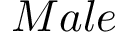Convert formula to latex. <formula><loc_0><loc_0><loc_500><loc_500>M a l e</formula> 